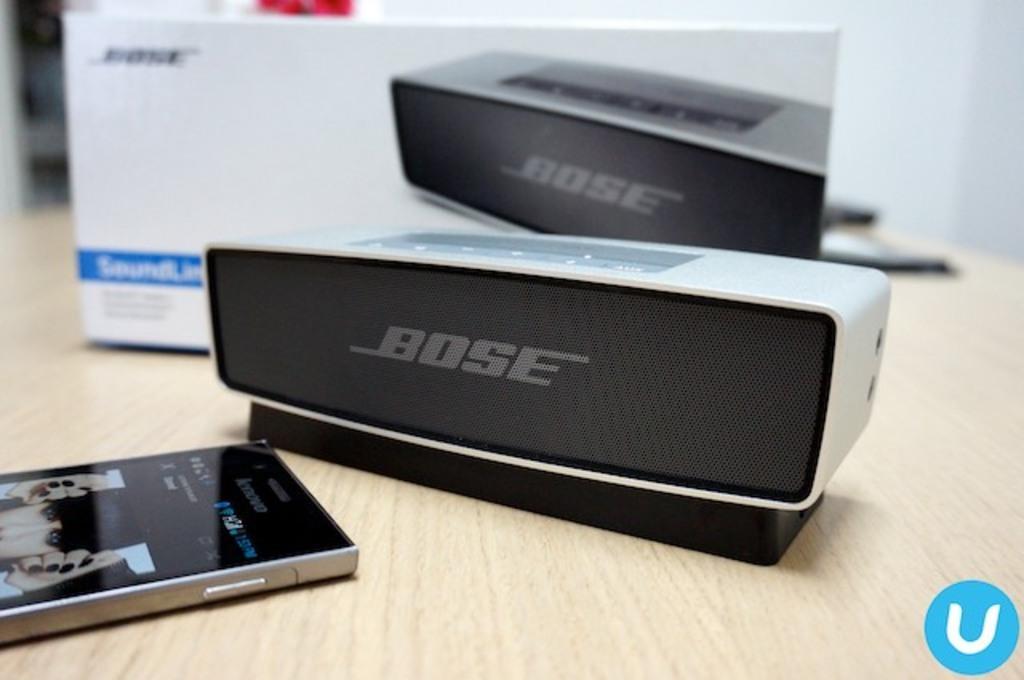Could you give a brief overview of what you see in this image? Here in this picture we can see a mobile phone, a speaker and its box present on the table. 